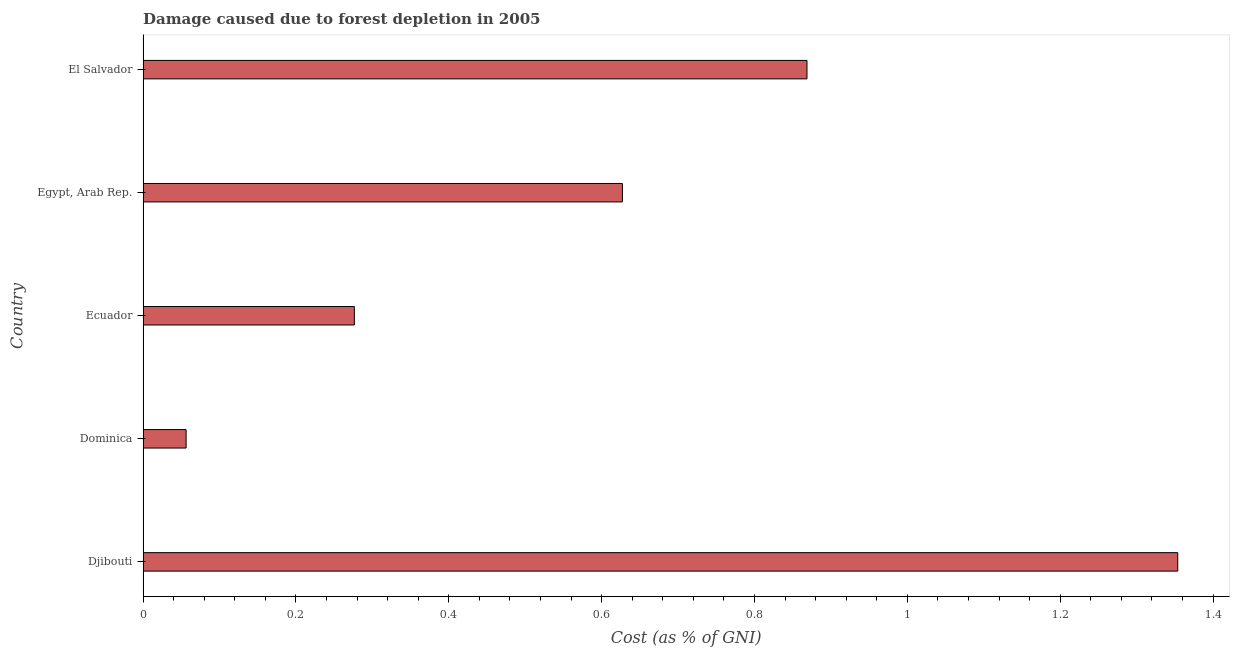Does the graph contain grids?
Ensure brevity in your answer.  No. What is the title of the graph?
Your answer should be very brief. Damage caused due to forest depletion in 2005. What is the label or title of the X-axis?
Your answer should be compact. Cost (as % of GNI). What is the label or title of the Y-axis?
Ensure brevity in your answer.  Country. What is the damage caused due to forest depletion in Egypt, Arab Rep.?
Ensure brevity in your answer.  0.63. Across all countries, what is the maximum damage caused due to forest depletion?
Provide a short and direct response. 1.35. Across all countries, what is the minimum damage caused due to forest depletion?
Your answer should be very brief. 0.06. In which country was the damage caused due to forest depletion maximum?
Provide a short and direct response. Djibouti. In which country was the damage caused due to forest depletion minimum?
Give a very brief answer. Dominica. What is the sum of the damage caused due to forest depletion?
Offer a very short reply. 3.18. What is the difference between the damage caused due to forest depletion in Djibouti and Dominica?
Keep it short and to the point. 1.3. What is the average damage caused due to forest depletion per country?
Make the answer very short. 0.64. What is the median damage caused due to forest depletion?
Offer a terse response. 0.63. In how many countries, is the damage caused due to forest depletion greater than 1.32 %?
Your answer should be very brief. 1. What is the ratio of the damage caused due to forest depletion in Dominica to that in Egypt, Arab Rep.?
Provide a short and direct response. 0.09. Is the damage caused due to forest depletion in Djibouti less than that in El Salvador?
Offer a terse response. No. What is the difference between the highest and the second highest damage caused due to forest depletion?
Your answer should be compact. 0.48. In how many countries, is the damage caused due to forest depletion greater than the average damage caused due to forest depletion taken over all countries?
Your response must be concise. 2. Are all the bars in the graph horizontal?
Your response must be concise. Yes. How many countries are there in the graph?
Provide a succinct answer. 5. What is the difference between two consecutive major ticks on the X-axis?
Keep it short and to the point. 0.2. What is the Cost (as % of GNI) of Djibouti?
Your answer should be compact. 1.35. What is the Cost (as % of GNI) in Dominica?
Your answer should be very brief. 0.06. What is the Cost (as % of GNI) of Ecuador?
Keep it short and to the point. 0.28. What is the Cost (as % of GNI) in Egypt, Arab Rep.?
Your answer should be compact. 0.63. What is the Cost (as % of GNI) of El Salvador?
Make the answer very short. 0.87. What is the difference between the Cost (as % of GNI) in Djibouti and Dominica?
Provide a short and direct response. 1.3. What is the difference between the Cost (as % of GNI) in Djibouti and Ecuador?
Keep it short and to the point. 1.08. What is the difference between the Cost (as % of GNI) in Djibouti and Egypt, Arab Rep.?
Your response must be concise. 0.73. What is the difference between the Cost (as % of GNI) in Djibouti and El Salvador?
Provide a short and direct response. 0.49. What is the difference between the Cost (as % of GNI) in Dominica and Ecuador?
Make the answer very short. -0.22. What is the difference between the Cost (as % of GNI) in Dominica and Egypt, Arab Rep.?
Keep it short and to the point. -0.57. What is the difference between the Cost (as % of GNI) in Dominica and El Salvador?
Offer a very short reply. -0.81. What is the difference between the Cost (as % of GNI) in Ecuador and Egypt, Arab Rep.?
Offer a very short reply. -0.35. What is the difference between the Cost (as % of GNI) in Ecuador and El Salvador?
Offer a very short reply. -0.59. What is the difference between the Cost (as % of GNI) in Egypt, Arab Rep. and El Salvador?
Keep it short and to the point. -0.24. What is the ratio of the Cost (as % of GNI) in Djibouti to that in Dominica?
Offer a terse response. 24.04. What is the ratio of the Cost (as % of GNI) in Djibouti to that in Ecuador?
Keep it short and to the point. 4.9. What is the ratio of the Cost (as % of GNI) in Djibouti to that in Egypt, Arab Rep.?
Your answer should be compact. 2.16. What is the ratio of the Cost (as % of GNI) in Djibouti to that in El Salvador?
Your response must be concise. 1.56. What is the ratio of the Cost (as % of GNI) in Dominica to that in Ecuador?
Provide a short and direct response. 0.2. What is the ratio of the Cost (as % of GNI) in Dominica to that in Egypt, Arab Rep.?
Keep it short and to the point. 0.09. What is the ratio of the Cost (as % of GNI) in Dominica to that in El Salvador?
Your answer should be compact. 0.07. What is the ratio of the Cost (as % of GNI) in Ecuador to that in Egypt, Arab Rep.?
Offer a very short reply. 0.44. What is the ratio of the Cost (as % of GNI) in Ecuador to that in El Salvador?
Your answer should be very brief. 0.32. What is the ratio of the Cost (as % of GNI) in Egypt, Arab Rep. to that in El Salvador?
Make the answer very short. 0.72. 